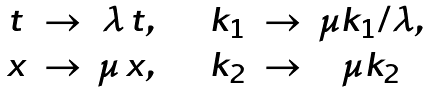<formula> <loc_0><loc_0><loc_500><loc_500>\begin{array} { c c r } t & \rightarrow & \lambda \, t , \\ x & \rightarrow & \mu \, x , \\ \end{array} \quad \begin{array} { c c c } k _ { 1 } & \rightarrow & \mu k _ { 1 } / \lambda , \\ k _ { 2 } & \rightarrow & \mu k _ { 2 } \end{array}</formula> 